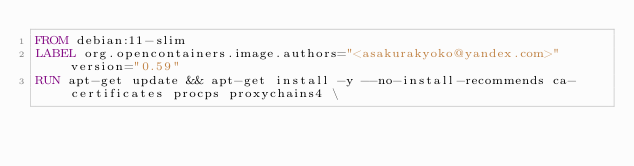Convert code to text. <code><loc_0><loc_0><loc_500><loc_500><_Dockerfile_>FROM debian:11-slim
LABEL org.opencontainers.image.authors="<asakurakyoko@yandex.com>" version="0.59"
RUN apt-get update && apt-get install -y --no-install-recommends ca-certificates procps proxychains4 \</code> 